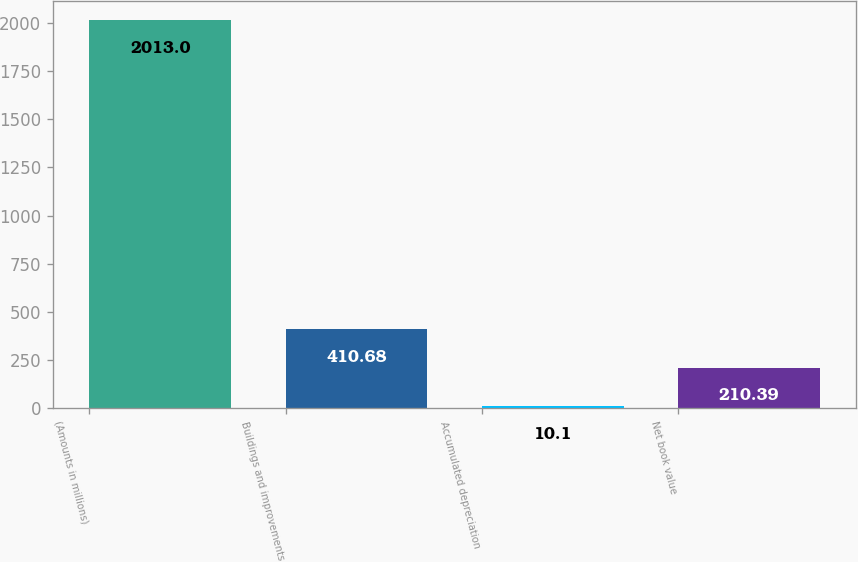Convert chart to OTSL. <chart><loc_0><loc_0><loc_500><loc_500><bar_chart><fcel>(Amounts in millions)<fcel>Buildings and improvements<fcel>Accumulated depreciation<fcel>Net book value<nl><fcel>2013<fcel>410.68<fcel>10.1<fcel>210.39<nl></chart> 